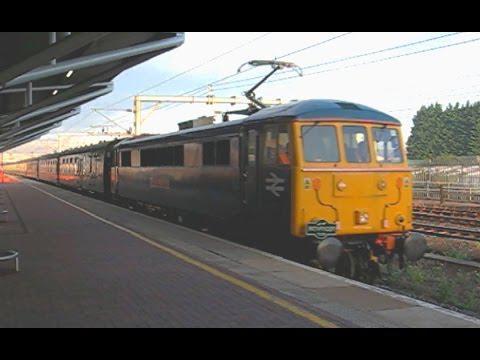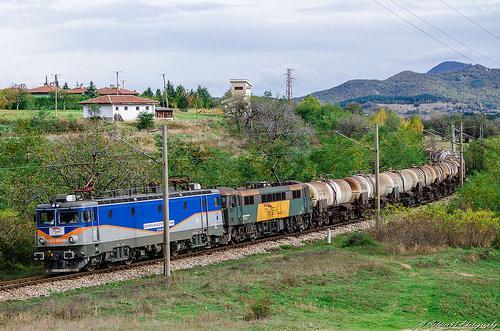The first image is the image on the left, the second image is the image on the right. Examine the images to the left and right. Is the description "The area on the front bottom of the train in the image on the left is yellow." accurate? Answer yes or no. Yes. The first image is the image on the left, the second image is the image on the right. Evaluate the accuracy of this statement regarding the images: "An image shows a train with a yellow front and a red side stripe, angled heading leftward.". Is it true? Answer yes or no. No. 